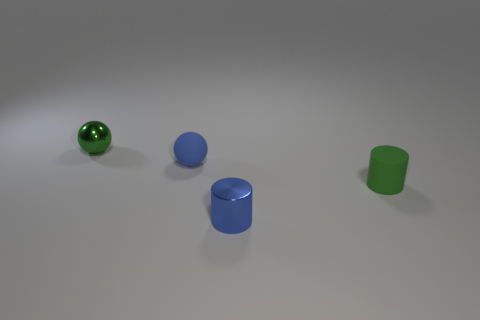What color is the small object to the left of the blue thing on the left side of the small metallic thing in front of the tiny green metallic sphere?
Provide a short and direct response. Green. Is there another thing that has the same shape as the small blue metal object?
Ensure brevity in your answer.  Yes. What color is the shiny cylinder that is the same size as the green matte thing?
Make the answer very short. Blue. There is a green object on the left side of the blue cylinder; what is its material?
Offer a very short reply. Metal. Is the shape of the small matte object that is to the left of the small green rubber thing the same as the thing that is to the right of the tiny blue cylinder?
Ensure brevity in your answer.  No. Is the number of small blue spheres left of the shiny ball the same as the number of tiny green objects?
Provide a succinct answer. No. What number of tiny objects are the same material as the tiny green cylinder?
Your response must be concise. 1. There is a small cylinder that is the same material as the blue sphere; what color is it?
Offer a very short reply. Green. The green metal object is what shape?
Offer a very short reply. Sphere. What number of tiny things have the same color as the tiny metal cylinder?
Provide a short and direct response. 1. 